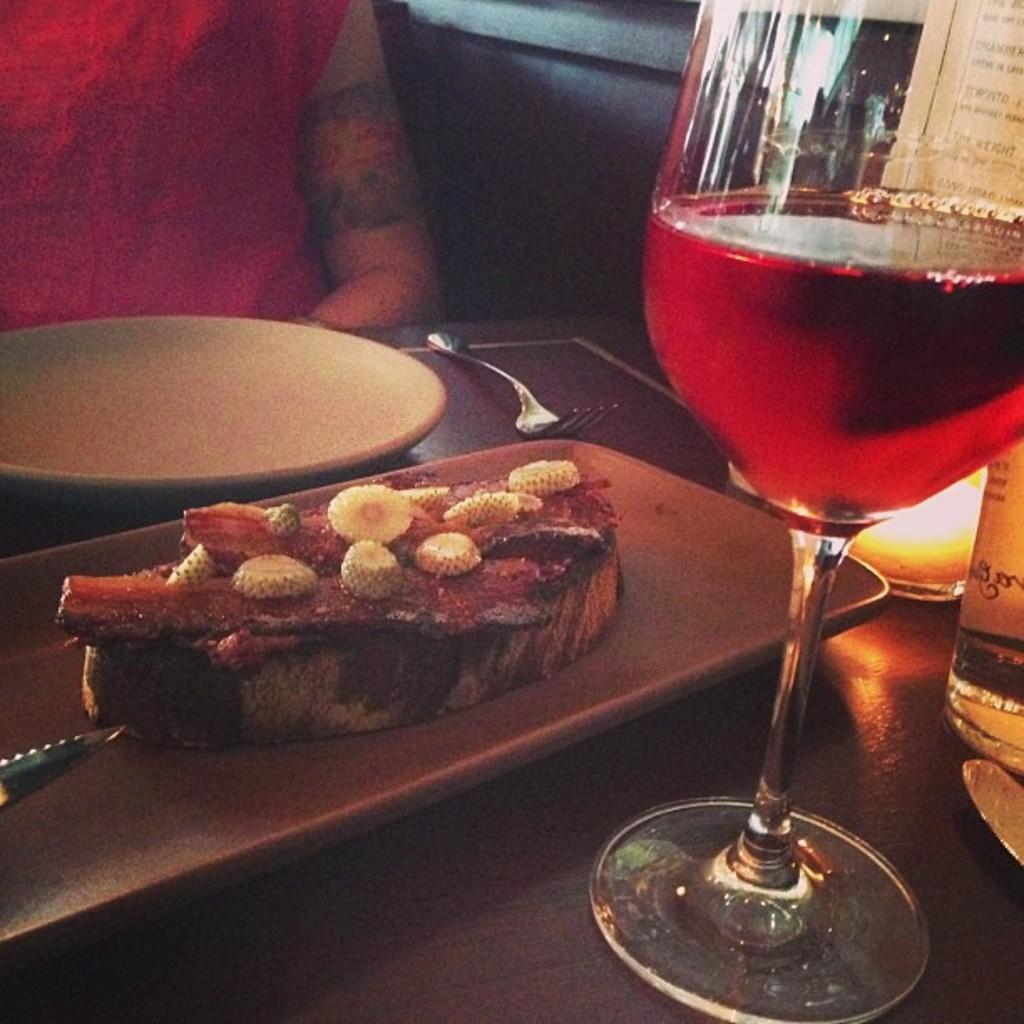In one or two sentences, can you explain what this image depicts? In this image we can see a table. On the table there are a serving plate which consists of cooked meat on it, beverage tumbler, beverage bottle and a fork. In the background we can see a person sitting on the chair. 